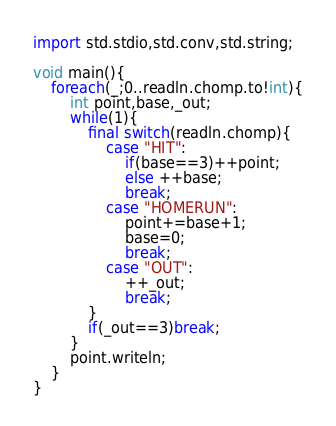Convert code to text. <code><loc_0><loc_0><loc_500><loc_500><_D_>import std.stdio,std.conv,std.string;

void main(){
    foreach(_;0..readln.chomp.to!int){
        int point,base,_out;
        while(1){
            final switch(readln.chomp){
                case "HIT":
                    if(base==3)++point;
                    else ++base;
                    break;
                case "HOMERUN":
                    point+=base+1;
                    base=0;
                    break;
                case "OUT":
                    ++_out;
                    break;
            }
            if(_out==3)break;
        }
        point.writeln;
    }
}</code> 